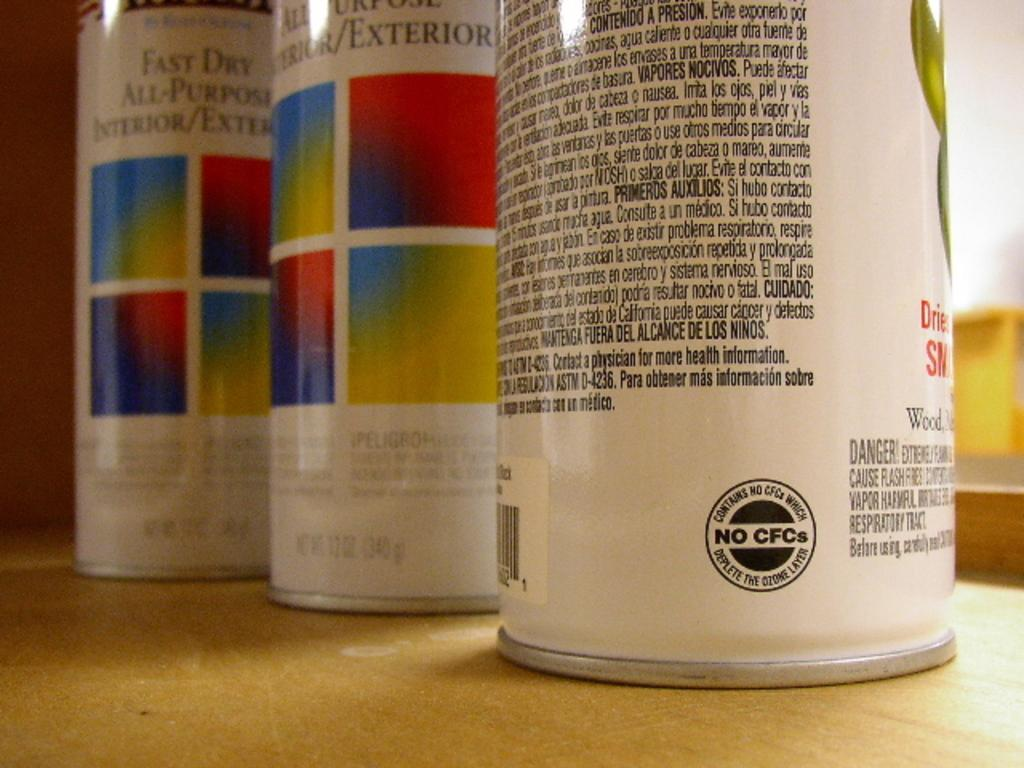Provide a one-sentence caption for the provided image. The three paint tins sitting on the table have No CFCs. 